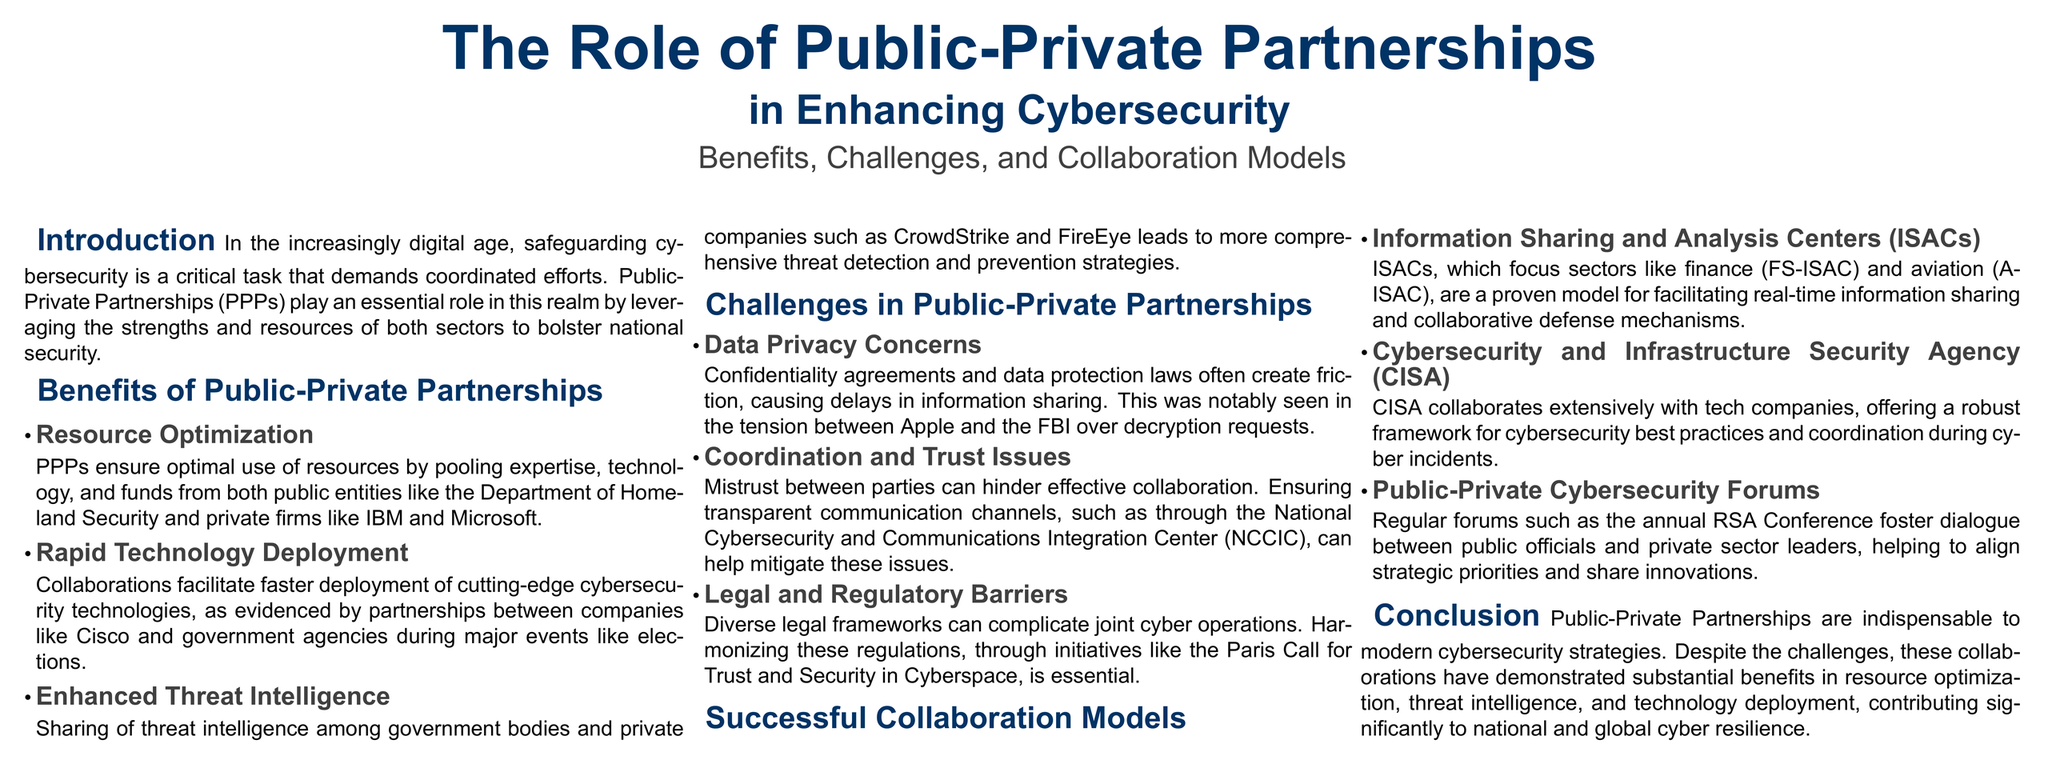What are the strengths leveraged in Public-Private Partnerships? The strengths leveraged include expertise, technology, and funds from both public entities and private firms.
Answer: Expertise, technology, and funds What challenge is associated with data privacy in PPPs? Data privacy concerns can cause delays in information sharing due to confidentiality agreements and data protection laws.
Answer: Data privacy concerns Which agency collaborates with tech companies for cybersecurity best practices? The Cybersecurity and Infrastructure Security Agency partners with tech companies offering a framework for best practices.
Answer: CISA What collaborative model focuses on real-time information sharing? Information Sharing and Analysis Centers (ISACs) are focused on real-time information sharing.
Answer: ISACs What significant event highlighted coordination and trust issues in cybersecurity? The tension between Apple and the FBI over decryption requests is a notable event highlighting these issues.
Answer: Apple and the FBI How do Public-Private Partnerships contribute to resource optimization? PPPs optimize resources by pooling expertise, technology, and funds from both sectors.
Answer: Pooling expertise, technology, and funds What is a proven model for facilitating collaborative defense mechanisms? Information Sharing and Analysis Centers (ISACs) are a proven model for collaboration in defense.
Answer: ISACs What key function do public-private cybersecurity forums serve? They foster dialogue between public officials and private leaders, aligning strategic priorities and sharing innovations.
Answer: Dialogue and alignment 